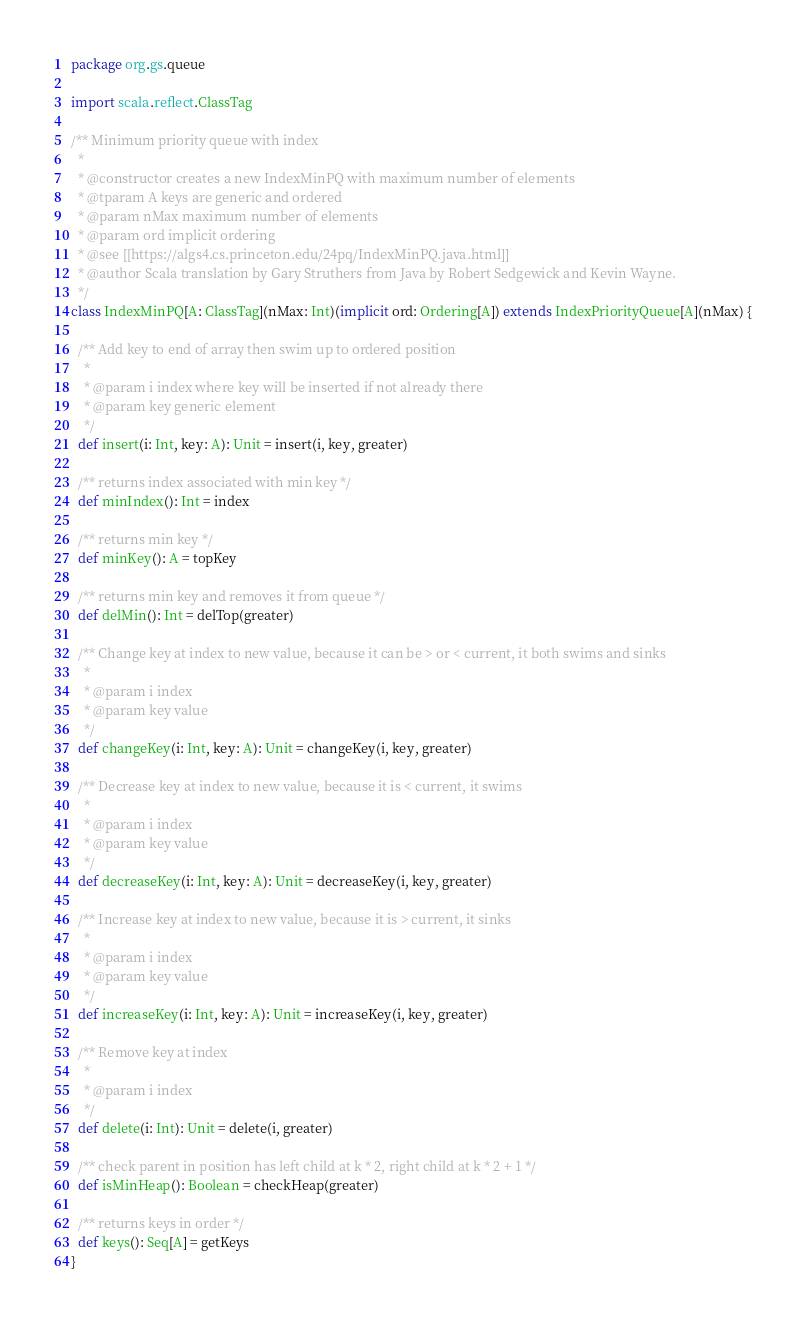<code> <loc_0><loc_0><loc_500><loc_500><_Scala_>package org.gs.queue

import scala.reflect.ClassTag

/** Minimum priority queue with index
  *
  * @constructor creates a new IndexMinPQ with maximum number of elements
  * @tparam A keys are generic and ordered
  * @param nMax maximum number of elements
  * @param ord implicit ordering
  * @see [[https://algs4.cs.princeton.edu/24pq/IndexMinPQ.java.html]]
  * @author Scala translation by Gary Struthers from Java by Robert Sedgewick and Kevin Wayne.
  */
class IndexMinPQ[A: ClassTag](nMax: Int)(implicit ord: Ordering[A]) extends IndexPriorityQueue[A](nMax) {

  /** Add key to end of array then swim up to ordered position
    *
    * @param i index where key will be inserted if not already there
    * @param key generic element
    */
  def insert(i: Int, key: A): Unit = insert(i, key, greater)

  /** returns index associated with min key */
  def minIndex(): Int = index

  /** returns min key */
  def minKey(): A = topKey

  /** returns min key and removes it from queue */
  def delMin(): Int = delTop(greater)

  /** Change key at index to new value, because it can be > or < current, it both swims and sinks
    *
    * @param i index
    * @param key value
    */
  def changeKey(i: Int, key: A): Unit = changeKey(i, key, greater)

  /** Decrease key at index to new value, because it is < current, it swims
    *
    * @param i index
    * @param key value
    */
  def decreaseKey(i: Int, key: A): Unit = decreaseKey(i, key, greater)

  /** Increase key at index to new value, because it is > current, it sinks
    *
    * @param i index
    * @param key value
    */
  def increaseKey(i: Int, key: A): Unit = increaseKey(i, key, greater)

  /** Remove key at index
    *
    * @param i index
    */
  def delete(i: Int): Unit = delete(i, greater)

  /** check parent in position has left child at k * 2, right child at k * 2 + 1 */
  def isMinHeap(): Boolean = checkHeap(greater)

  /** returns keys in order */
  def keys(): Seq[A] = getKeys
}
</code> 